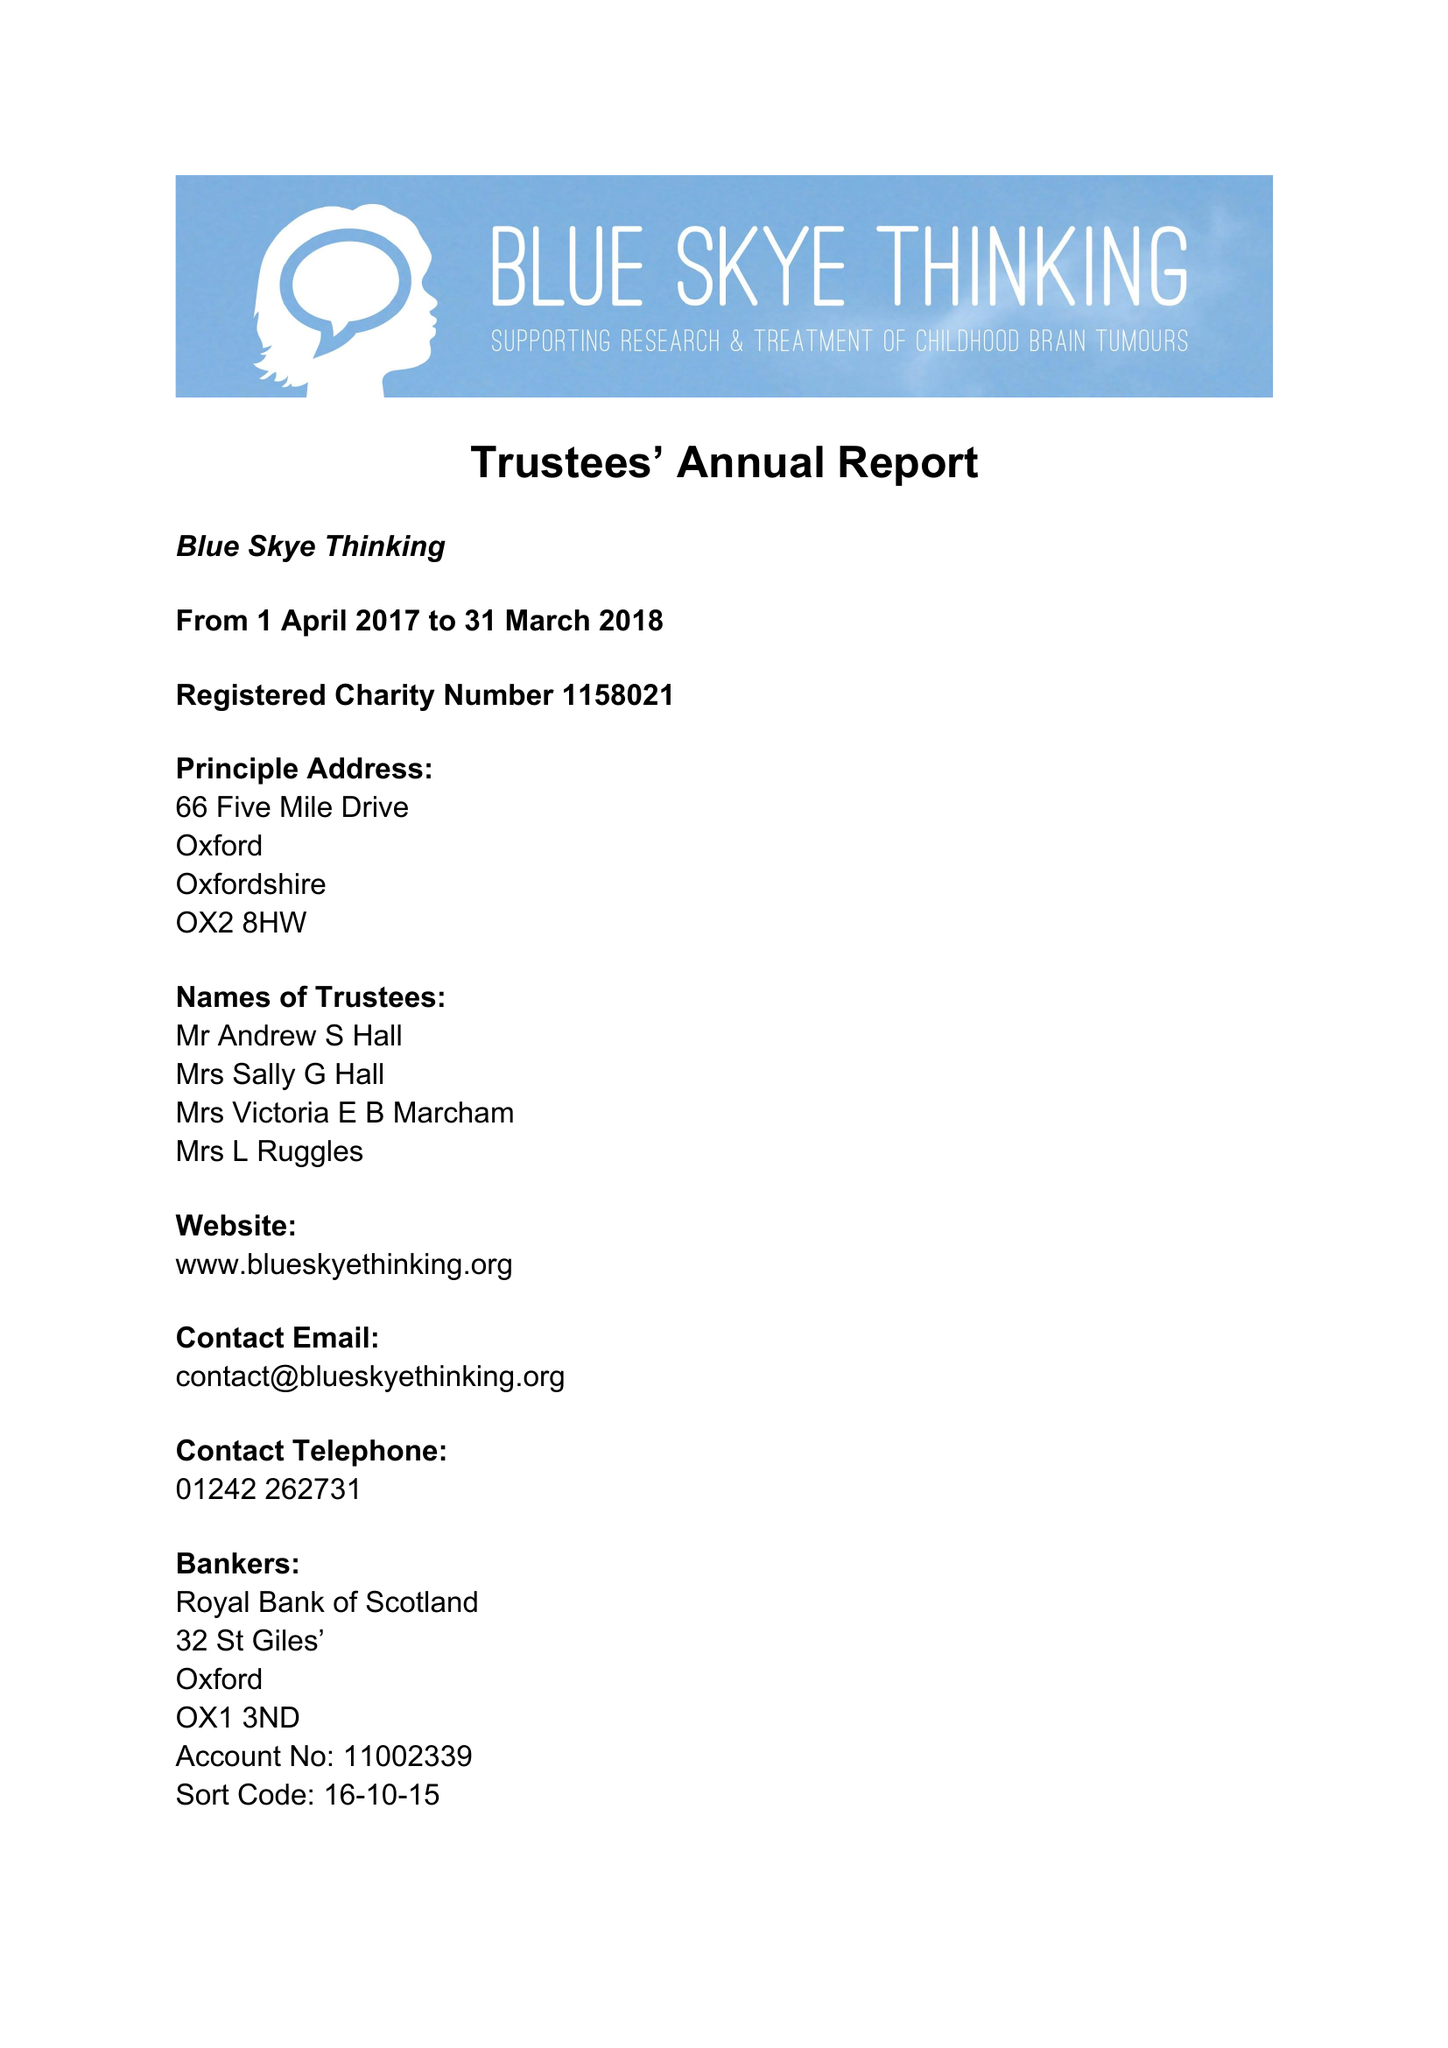What is the value for the address__post_town?
Answer the question using a single word or phrase. OXFORD 